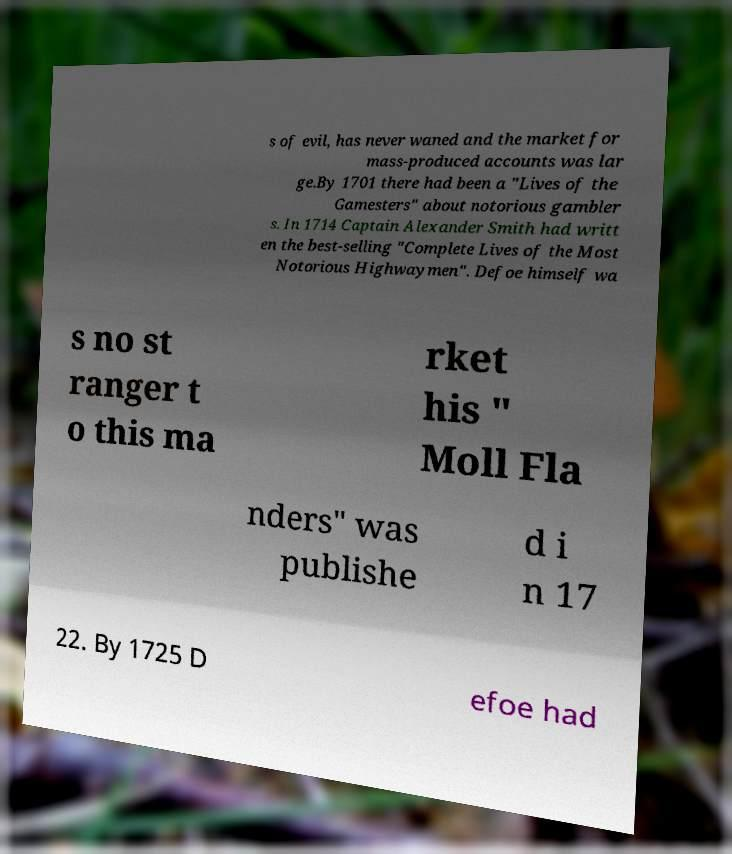Please identify and transcribe the text found in this image. s of evil, has never waned and the market for mass-produced accounts was lar ge.By 1701 there had been a "Lives of the Gamesters" about notorious gambler s. In 1714 Captain Alexander Smith had writt en the best-selling "Complete Lives of the Most Notorious Highwaymen". Defoe himself wa s no st ranger t o this ma rket his " Moll Fla nders" was publishe d i n 17 22. By 1725 D efoe had 